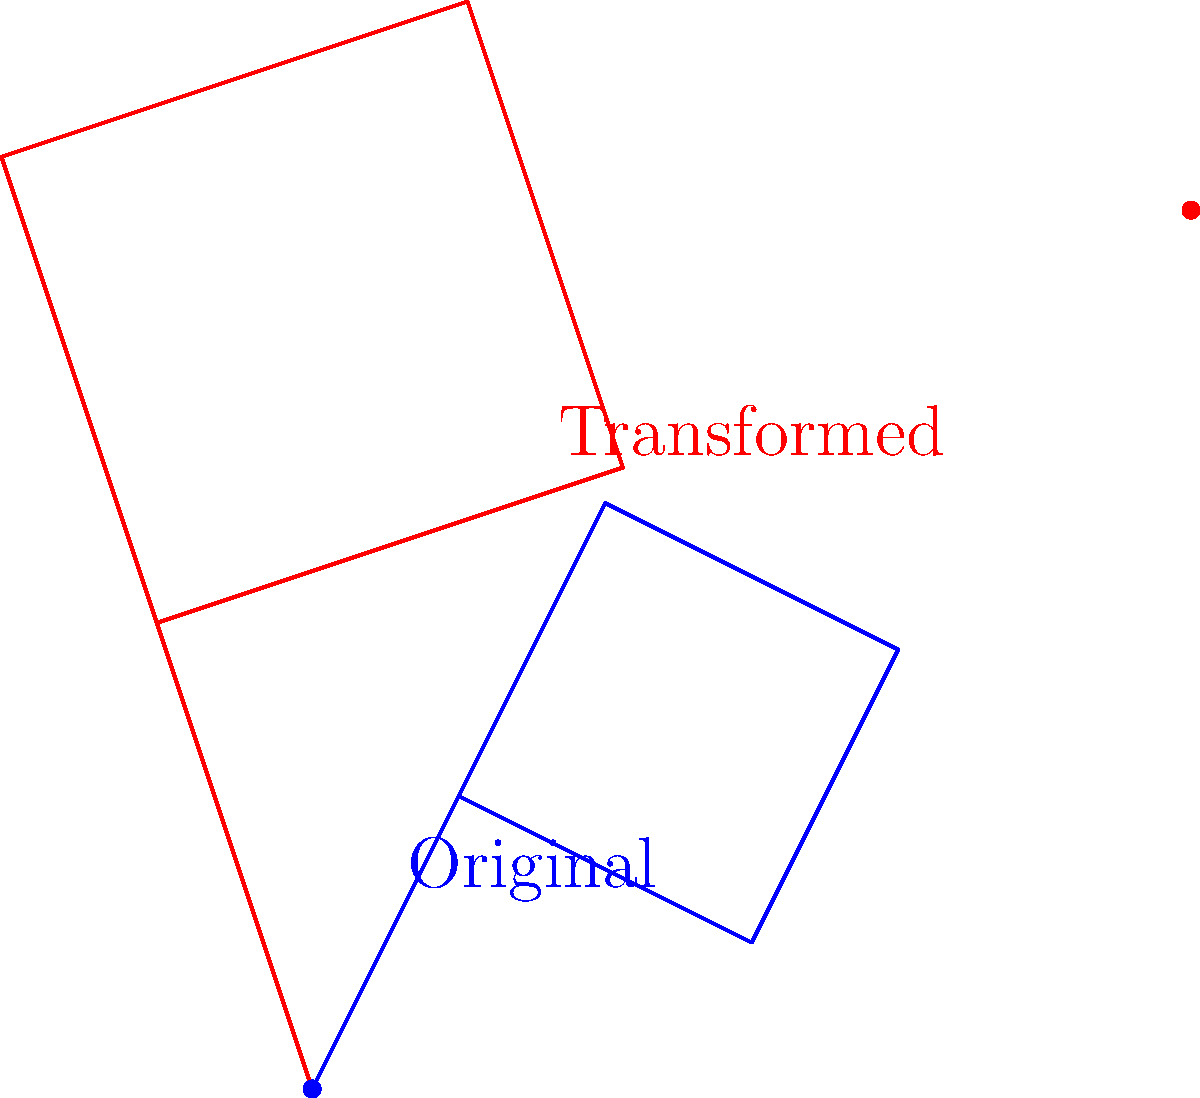In designing a surrealist film set, you've created a geometric shape that needs to be transformed for a dream sequence. The original shape is represented by the blue polygon, and the transformed shape is shown in red. If the transformation involves scaling by a factor of 1.5 and rotating by 45 degrees, what is the coordinates of the point $(0,0)$ in the original shape after the transformation? To find the coordinates of the transformed point, we need to apply the scaling and rotation transformations in order:

1. Scaling by 1.5:
   - The point $(0,0)$ remains at $(0,0)$ after scaling.

2. Rotation by 45 degrees:
   - We use the rotation matrix: 
     $R = \begin{pmatrix} \cos 45° & -\sin 45° \\ \sin 45° & \cos 45° \end{pmatrix}$
   - $\cos 45° = \sin 45° = \frac{\sqrt{2}}{2}$
   - Applying the rotation to $(0,0)$:
     $\begin{pmatrix} \frac{\sqrt{2}}{2} & -\frac{\sqrt{2}}{2} \\ \frac{\sqrt{2}}{2} & \frac{\sqrt{2}}{2} \end{pmatrix} \begin{pmatrix} 0 \\ 0 \end{pmatrix} = \begin{pmatrix} 0 \\ 0 \end{pmatrix}$

Therefore, the point $(0,0)$ remains at $(0,0)$ after both transformations.
Answer: $(0,0)$ 